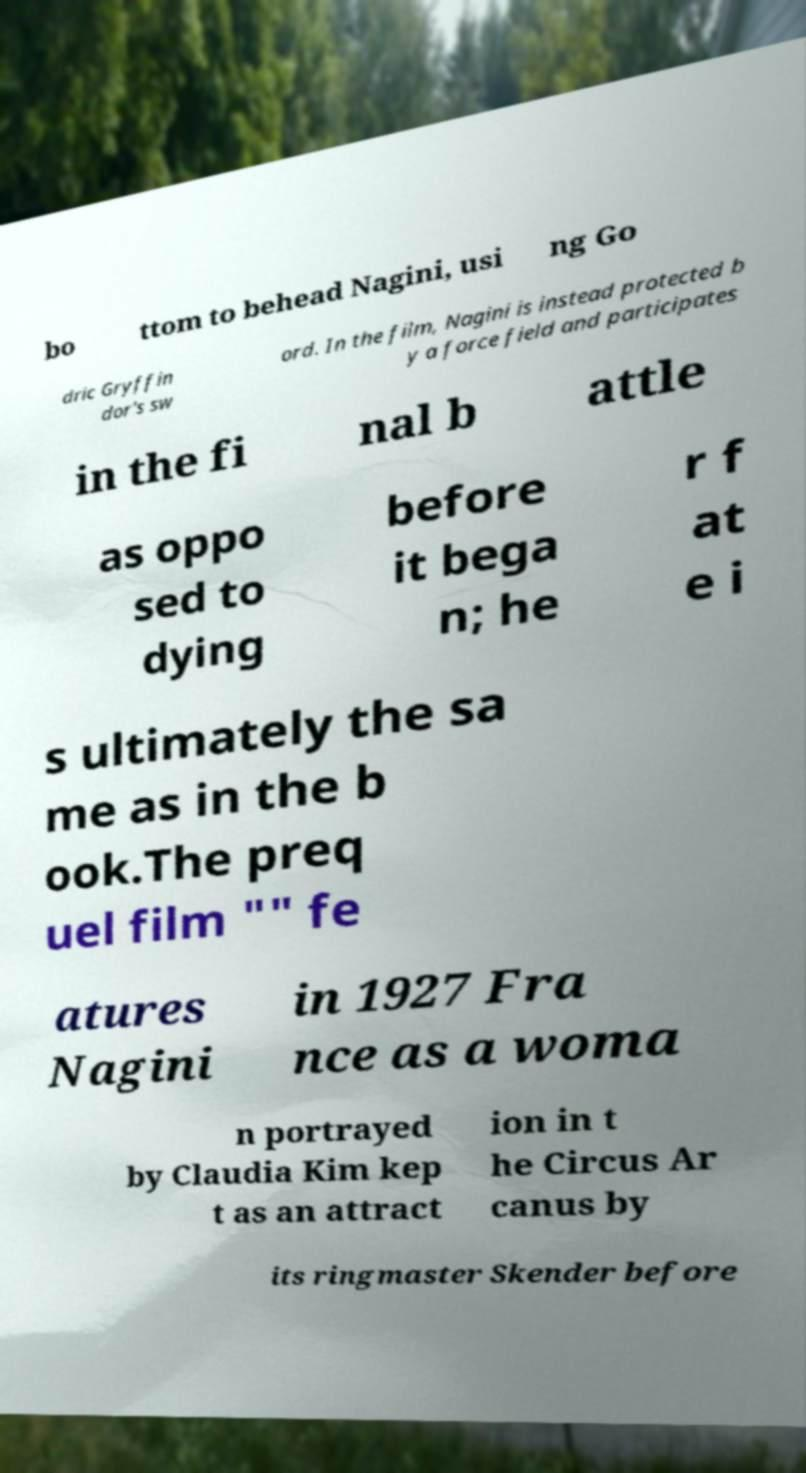For documentation purposes, I need the text within this image transcribed. Could you provide that? bo ttom to behead Nagini, usi ng Go dric Gryffin dor's sw ord. In the film, Nagini is instead protected b y a force field and participates in the fi nal b attle as oppo sed to dying before it bega n; he r f at e i s ultimately the sa me as in the b ook.The preq uel film "" fe atures Nagini in 1927 Fra nce as a woma n portrayed by Claudia Kim kep t as an attract ion in t he Circus Ar canus by its ringmaster Skender before 